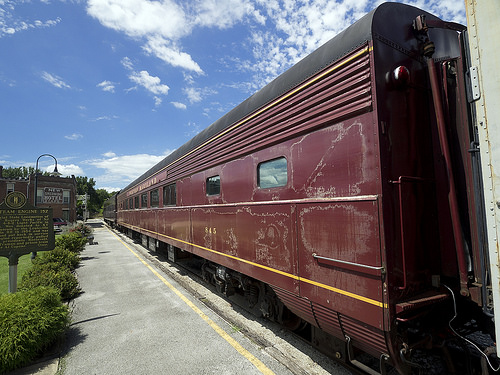<image>
Is the train above the bush? No. The train is not positioned above the bush. The vertical arrangement shows a different relationship. 